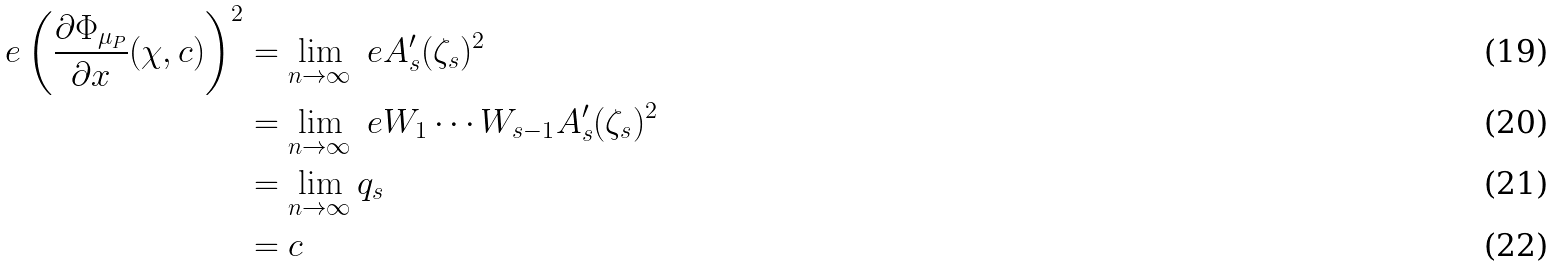<formula> <loc_0><loc_0><loc_500><loc_500>\ e \left ( \frac { \partial \Phi _ { \mu _ { P } } } { \partial x } ( \chi , c ) \right ) ^ { 2 } & = \lim _ { n \rightarrow \infty } \ e A _ { s } ^ { \prime } ( \zeta _ { s } ) ^ { 2 } \\ & = \lim _ { n \rightarrow \infty } \ e W _ { 1 } \cdots W _ { s - 1 } A _ { s } ^ { \prime } ( \zeta _ { s } ) ^ { 2 } \\ & = \lim _ { n \rightarrow \infty } q _ { s } \\ & = c</formula> 